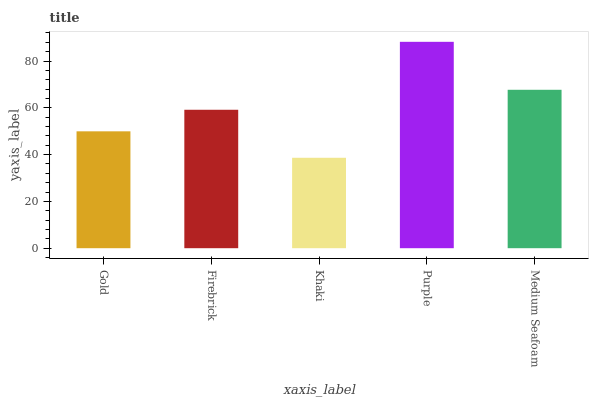Is Firebrick the minimum?
Answer yes or no. No. Is Firebrick the maximum?
Answer yes or no. No. Is Firebrick greater than Gold?
Answer yes or no. Yes. Is Gold less than Firebrick?
Answer yes or no. Yes. Is Gold greater than Firebrick?
Answer yes or no. No. Is Firebrick less than Gold?
Answer yes or no. No. Is Firebrick the high median?
Answer yes or no. Yes. Is Firebrick the low median?
Answer yes or no. Yes. Is Purple the high median?
Answer yes or no. No. Is Khaki the low median?
Answer yes or no. No. 